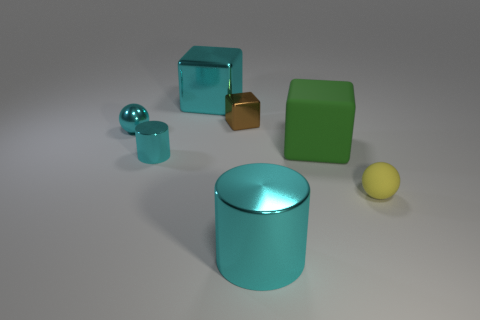Add 1 rubber cubes. How many objects exist? 8 Subtract all spheres. How many objects are left? 5 Subtract 1 brown blocks. How many objects are left? 6 Subtract all big blue matte cubes. Subtract all brown metal blocks. How many objects are left? 6 Add 6 tiny cyan things. How many tiny cyan things are left? 8 Add 4 large green objects. How many large green objects exist? 5 